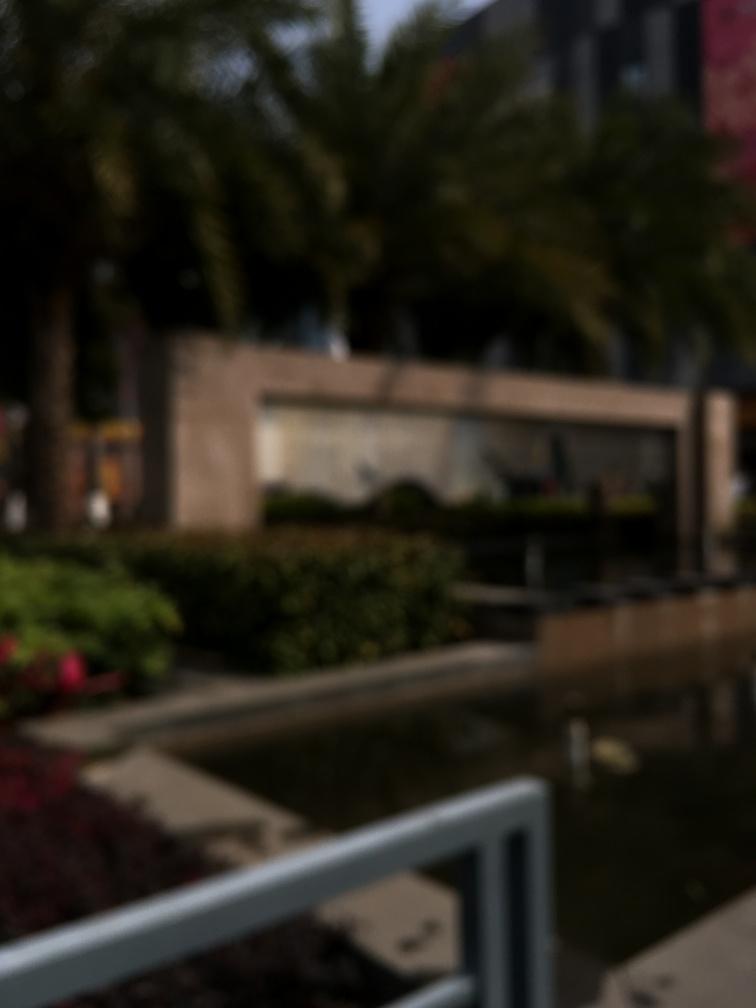In what ways could this image be improved or made clearer? To improve the clarity of the image, one could use photo editing software to adjust sharpness, although there's a limit to how much detail can be retrieved from such a blurry picture. Alternatively, re-taking the photograph with a steady hand, proper focus, and higher camera resolution would be the most effective solution. 